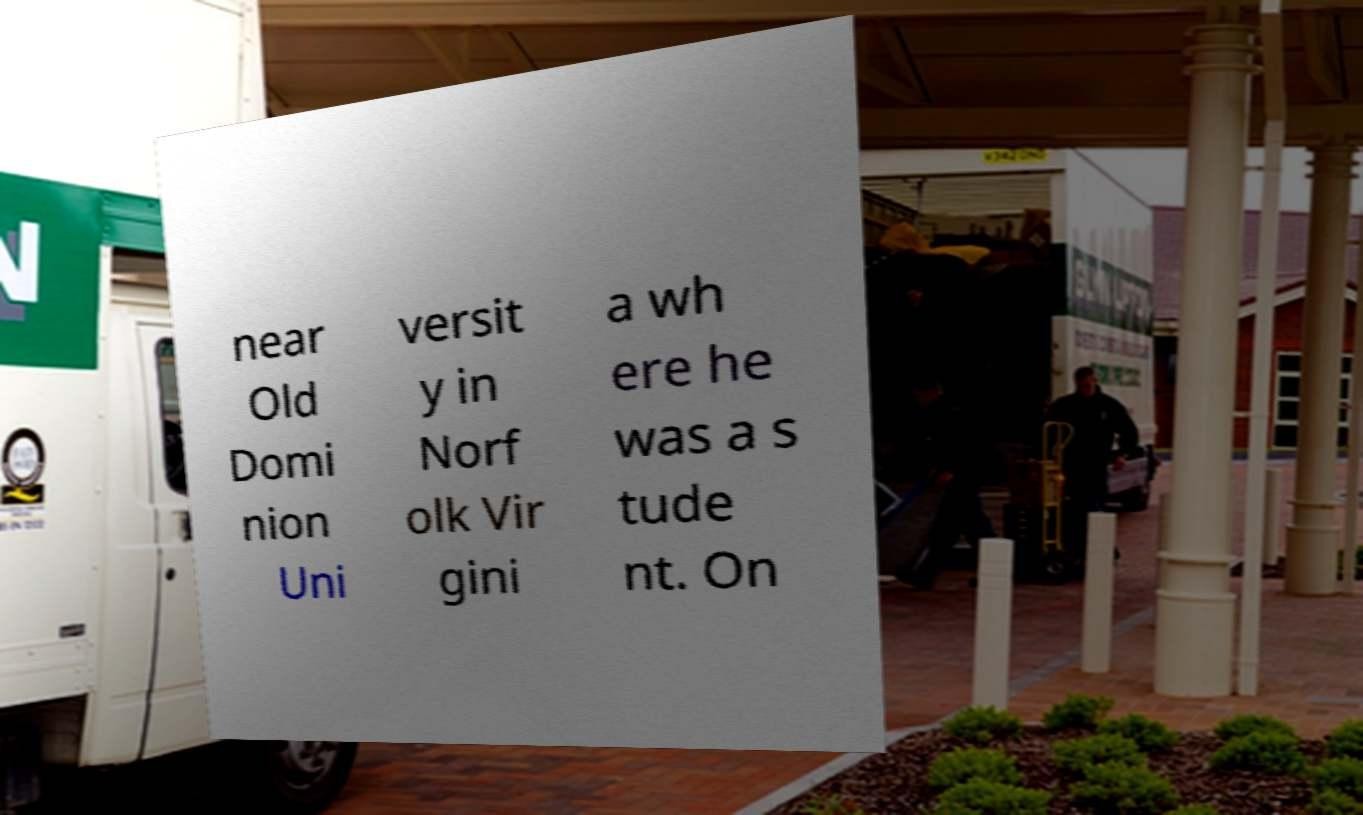What messages or text are displayed in this image? I need them in a readable, typed format. near Old Domi nion Uni versit y in Norf olk Vir gini a wh ere he was a s tude nt. On 